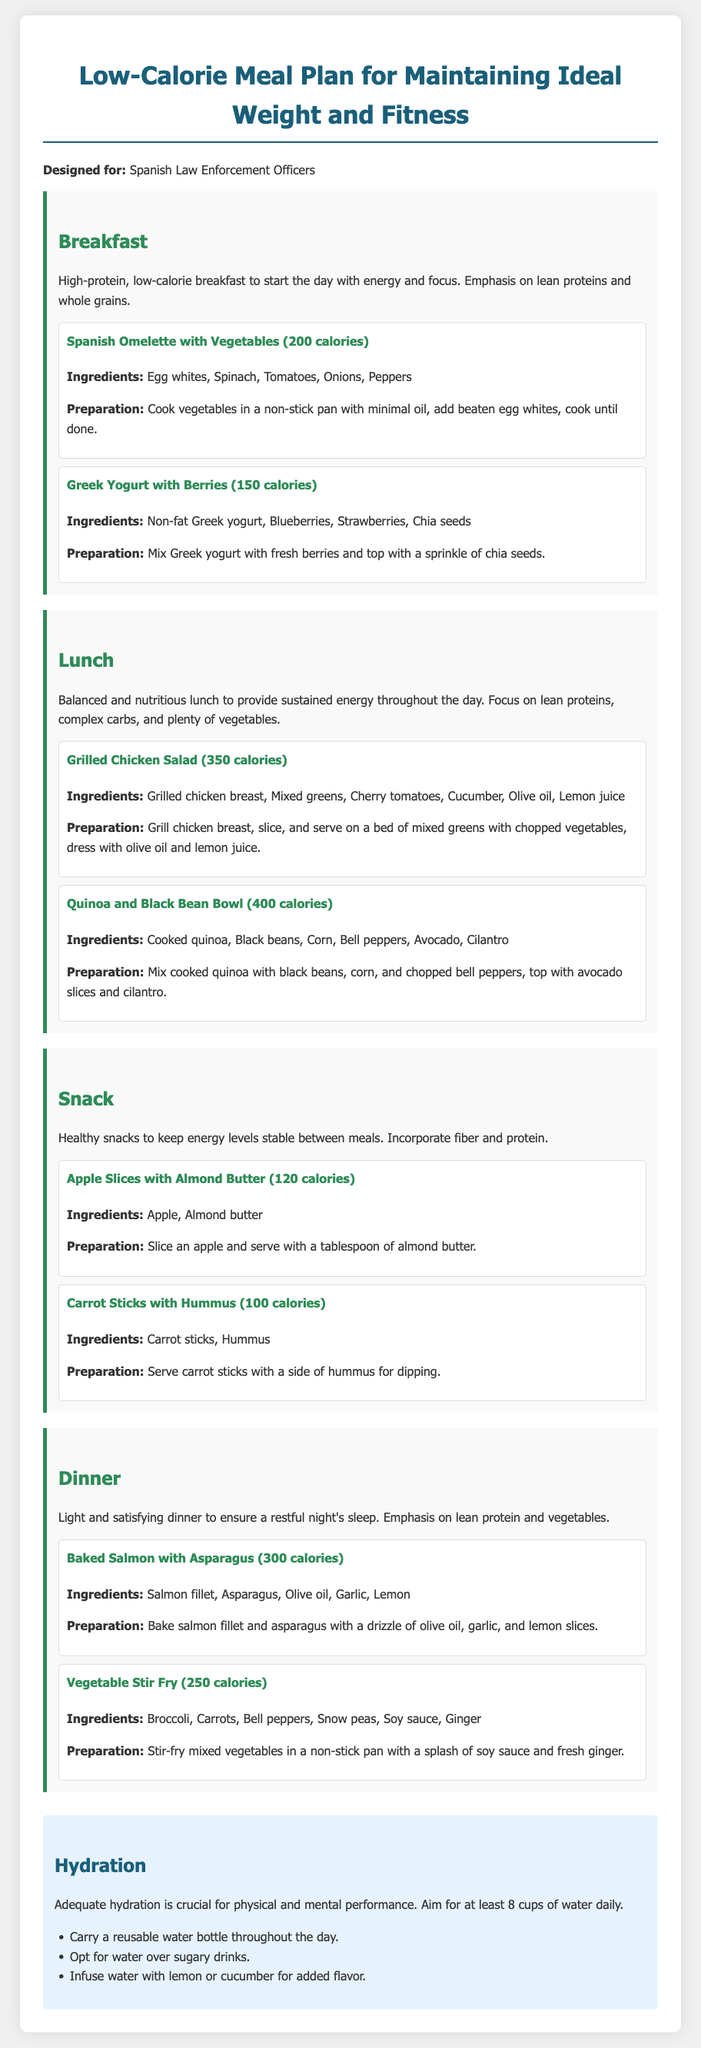What is the main purpose of the meal plan? The main purpose is to provide a low-calorie meal plan for maintaining ideal weight and fitness specifically designed for Spanish law enforcement officers.
Answer: Low-calorie meal plan How many calories are in the Spanish Omelette with Vegetables? The document states that the Spanish Omelette with Vegetables has 200 calories.
Answer: 200 calories What are the first meal options listed for breakfast? The first two meal options for breakfast are the Spanish Omelette with Vegetables and Greek Yogurt with Berries.
Answer: Spanish Omelette with Vegetables, Greek Yogurt with Berries What ingredient is included in both the Grilled Chicken Salad and the Quinoa and Black Bean Bowl? Both meals contain mixed greens, which are part of the Grilled Chicken Salad.
Answer: Mixed greens How many cups of water should be consumed daily? The document suggests aiming for at least 8 cups of water daily for adequate hydration.
Answer: 8 cups What is listed as a healthy snack option? Apple Slices with Almond Butter and Carrot Sticks with Hummus are both listed as healthy snack options.
Answer: Apple Slices with Almond Butter, Carrot Sticks with Hummus Which meal option is specifically focused on lean proteins and vegetables for dinner? Baked Salmon with Asparagus focuses on lean proteins and vegetables for dinner.
Answer: Baked Salmon with Asparagus What cooking method is recommended for the Vegetable Stir Fry? The document recommends stir-frying the mixed vegetables in a non-stick pan.
Answer: Stir-frying What is a suggested way to flavor water? A suggested way to flavor water is to infuse it with lemon or cucumber.
Answer: Infuse with lemon or cucumber 